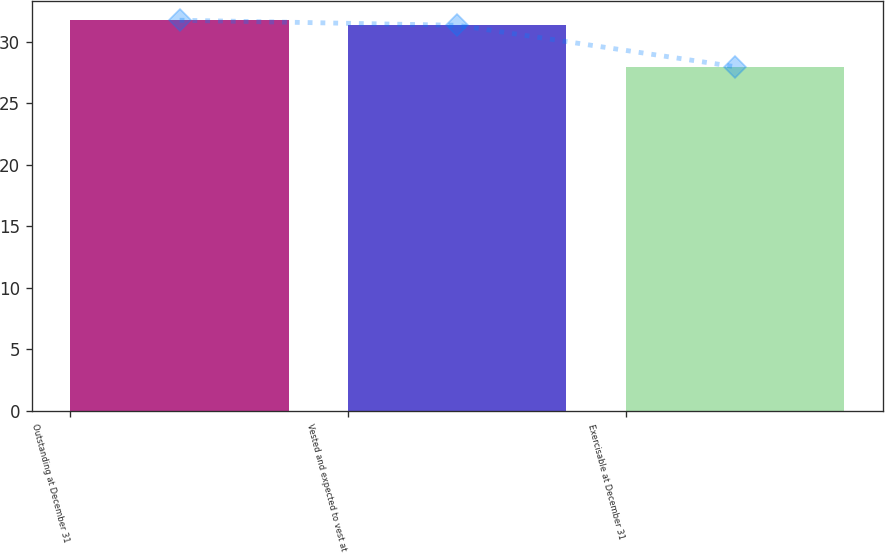Convert chart. <chart><loc_0><loc_0><loc_500><loc_500><bar_chart><fcel>Outstanding at December 31<fcel>Vested and expected to vest at<fcel>Exercisable at December 31<nl><fcel>31.74<fcel>31.33<fcel>27.97<nl></chart> 